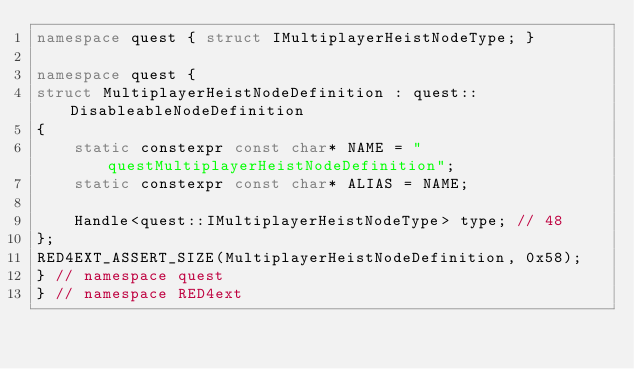Convert code to text. <code><loc_0><loc_0><loc_500><loc_500><_C++_>namespace quest { struct IMultiplayerHeistNodeType; }

namespace quest { 
struct MultiplayerHeistNodeDefinition : quest::DisableableNodeDefinition
{
    static constexpr const char* NAME = "questMultiplayerHeistNodeDefinition";
    static constexpr const char* ALIAS = NAME;

    Handle<quest::IMultiplayerHeistNodeType> type; // 48
};
RED4EXT_ASSERT_SIZE(MultiplayerHeistNodeDefinition, 0x58);
} // namespace quest
} // namespace RED4ext
</code> 